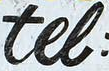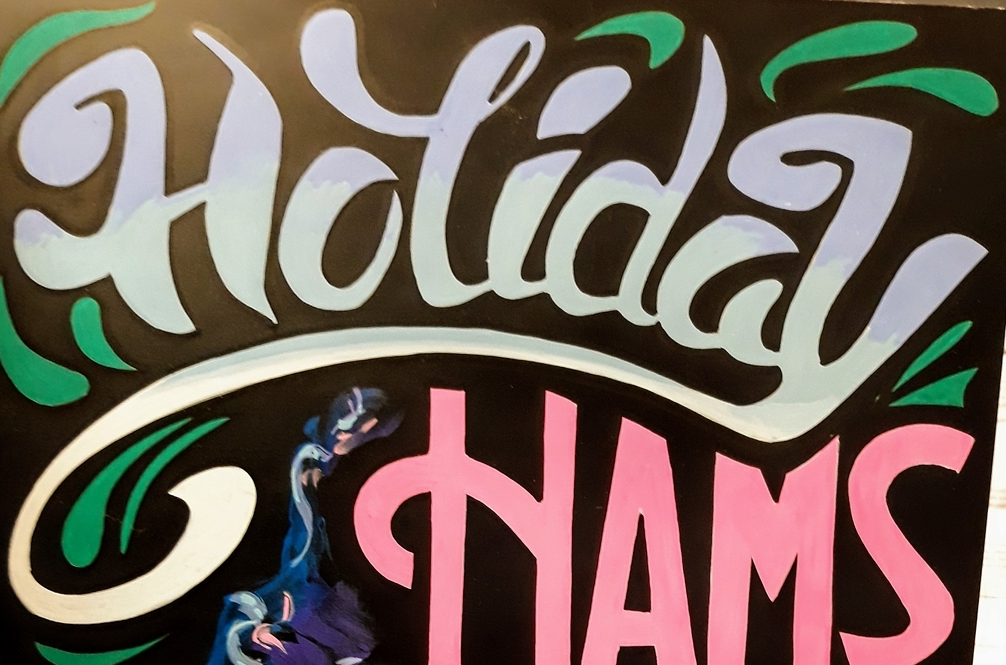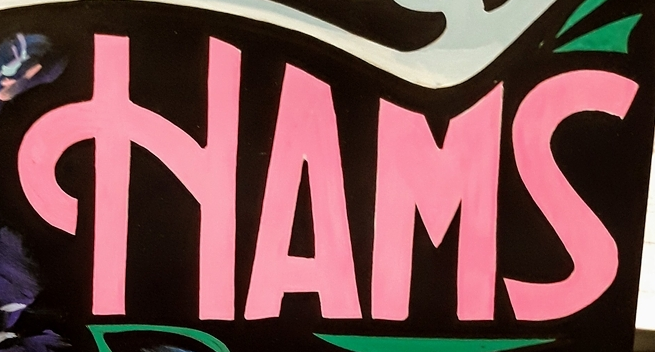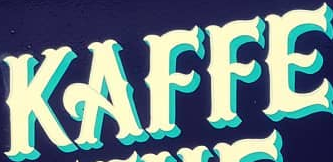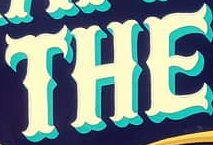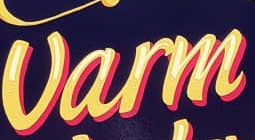What words are shown in these images in order, separated by a semicolon? tel; Holiday; HAMS; KAFFE; THE; Varm 